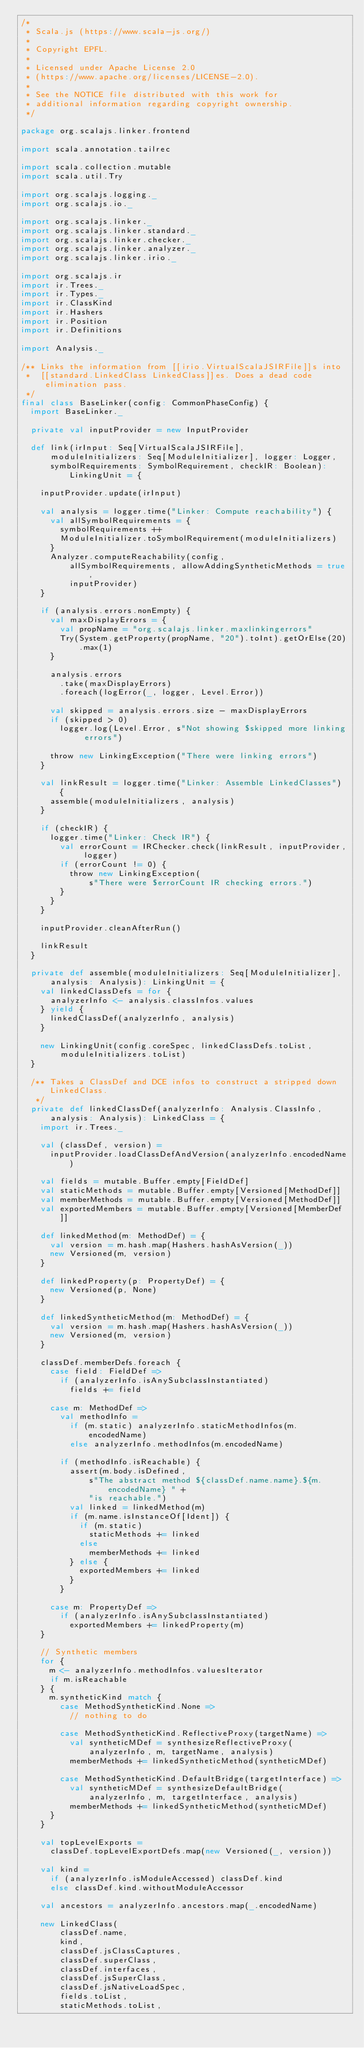Convert code to text. <code><loc_0><loc_0><loc_500><loc_500><_Scala_>/*
 * Scala.js (https://www.scala-js.org/)
 *
 * Copyright EPFL.
 *
 * Licensed under Apache License 2.0
 * (https://www.apache.org/licenses/LICENSE-2.0).
 *
 * See the NOTICE file distributed with this work for
 * additional information regarding copyright ownership.
 */

package org.scalajs.linker.frontend

import scala.annotation.tailrec

import scala.collection.mutable
import scala.util.Try

import org.scalajs.logging._
import org.scalajs.io._

import org.scalajs.linker._
import org.scalajs.linker.standard._
import org.scalajs.linker.checker._
import org.scalajs.linker.analyzer._
import org.scalajs.linker.irio._

import org.scalajs.ir
import ir.Trees._
import ir.Types._
import ir.ClassKind
import ir.Hashers
import ir.Position
import ir.Definitions

import Analysis._

/** Links the information from [[irio.VirtualScalaJSIRFile]]s into
 *  [[standard.LinkedClass LinkedClass]]es. Does a dead code elimination pass.
 */
final class BaseLinker(config: CommonPhaseConfig) {
  import BaseLinker._

  private val inputProvider = new InputProvider

  def link(irInput: Seq[VirtualScalaJSIRFile],
      moduleInitializers: Seq[ModuleInitializer], logger: Logger,
      symbolRequirements: SymbolRequirement, checkIR: Boolean): LinkingUnit = {

    inputProvider.update(irInput)

    val analysis = logger.time("Linker: Compute reachability") {
      val allSymbolRequirements = {
        symbolRequirements ++
        ModuleInitializer.toSymbolRequirement(moduleInitializers)
      }
      Analyzer.computeReachability(config,
          allSymbolRequirements, allowAddingSyntheticMethods = true,
          inputProvider)
    }

    if (analysis.errors.nonEmpty) {
      val maxDisplayErrors = {
        val propName = "org.scalajs.linker.maxlinkingerrors"
        Try(System.getProperty(propName, "20").toInt).getOrElse(20).max(1)
      }

      analysis.errors
        .take(maxDisplayErrors)
        .foreach(logError(_, logger, Level.Error))

      val skipped = analysis.errors.size - maxDisplayErrors
      if (skipped > 0)
        logger.log(Level.Error, s"Not showing $skipped more linking errors")

      throw new LinkingException("There were linking errors")
    }

    val linkResult = logger.time("Linker: Assemble LinkedClasses") {
      assemble(moduleInitializers, analysis)
    }

    if (checkIR) {
      logger.time("Linker: Check IR") {
        val errorCount = IRChecker.check(linkResult, inputProvider, logger)
        if (errorCount != 0) {
          throw new LinkingException(
              s"There were $errorCount IR checking errors.")
        }
      }
    }

    inputProvider.cleanAfterRun()

    linkResult
  }

  private def assemble(moduleInitializers: Seq[ModuleInitializer],
      analysis: Analysis): LinkingUnit = {
    val linkedClassDefs = for {
      analyzerInfo <- analysis.classInfos.values
    } yield {
      linkedClassDef(analyzerInfo, analysis)
    }

    new LinkingUnit(config.coreSpec, linkedClassDefs.toList,
        moduleInitializers.toList)
  }

  /** Takes a ClassDef and DCE infos to construct a stripped down LinkedClass.
   */
  private def linkedClassDef(analyzerInfo: Analysis.ClassInfo,
      analysis: Analysis): LinkedClass = {
    import ir.Trees._

    val (classDef, version) =
      inputProvider.loadClassDefAndVersion(analyzerInfo.encodedName)

    val fields = mutable.Buffer.empty[FieldDef]
    val staticMethods = mutable.Buffer.empty[Versioned[MethodDef]]
    val memberMethods = mutable.Buffer.empty[Versioned[MethodDef]]
    val exportedMembers = mutable.Buffer.empty[Versioned[MemberDef]]

    def linkedMethod(m: MethodDef) = {
      val version = m.hash.map(Hashers.hashAsVersion(_))
      new Versioned(m, version)
    }

    def linkedProperty(p: PropertyDef) = {
      new Versioned(p, None)
    }

    def linkedSyntheticMethod(m: MethodDef) = {
      val version = m.hash.map(Hashers.hashAsVersion(_))
      new Versioned(m, version)
    }

    classDef.memberDefs.foreach {
      case field: FieldDef =>
        if (analyzerInfo.isAnySubclassInstantiated)
          fields += field

      case m: MethodDef =>
        val methodInfo =
          if (m.static) analyzerInfo.staticMethodInfos(m.encodedName)
          else analyzerInfo.methodInfos(m.encodedName)

        if (methodInfo.isReachable) {
          assert(m.body.isDefined,
              s"The abstract method ${classDef.name.name}.${m.encodedName} " +
              "is reachable.")
          val linked = linkedMethod(m)
          if (m.name.isInstanceOf[Ident]) {
            if (m.static)
              staticMethods += linked
            else
              memberMethods += linked
          } else {
            exportedMembers += linked
          }
        }

      case m: PropertyDef =>
        if (analyzerInfo.isAnySubclassInstantiated)
          exportedMembers += linkedProperty(m)
    }

    // Synthetic members
    for {
      m <- analyzerInfo.methodInfos.valuesIterator
      if m.isReachable
    } {
      m.syntheticKind match {
        case MethodSyntheticKind.None =>
          // nothing to do

        case MethodSyntheticKind.ReflectiveProxy(targetName) =>
          val syntheticMDef = synthesizeReflectiveProxy(
              analyzerInfo, m, targetName, analysis)
          memberMethods += linkedSyntheticMethod(syntheticMDef)

        case MethodSyntheticKind.DefaultBridge(targetInterface) =>
          val syntheticMDef = synthesizeDefaultBridge(
              analyzerInfo, m, targetInterface, analysis)
          memberMethods += linkedSyntheticMethod(syntheticMDef)
      }
    }

    val topLevelExports =
      classDef.topLevelExportDefs.map(new Versioned(_, version))

    val kind =
      if (analyzerInfo.isModuleAccessed) classDef.kind
      else classDef.kind.withoutModuleAccessor

    val ancestors = analyzerInfo.ancestors.map(_.encodedName)

    new LinkedClass(
        classDef.name,
        kind,
        classDef.jsClassCaptures,
        classDef.superClass,
        classDef.interfaces,
        classDef.jsSuperClass,
        classDef.jsNativeLoadSpec,
        fields.toList,
        staticMethods.toList,</code> 